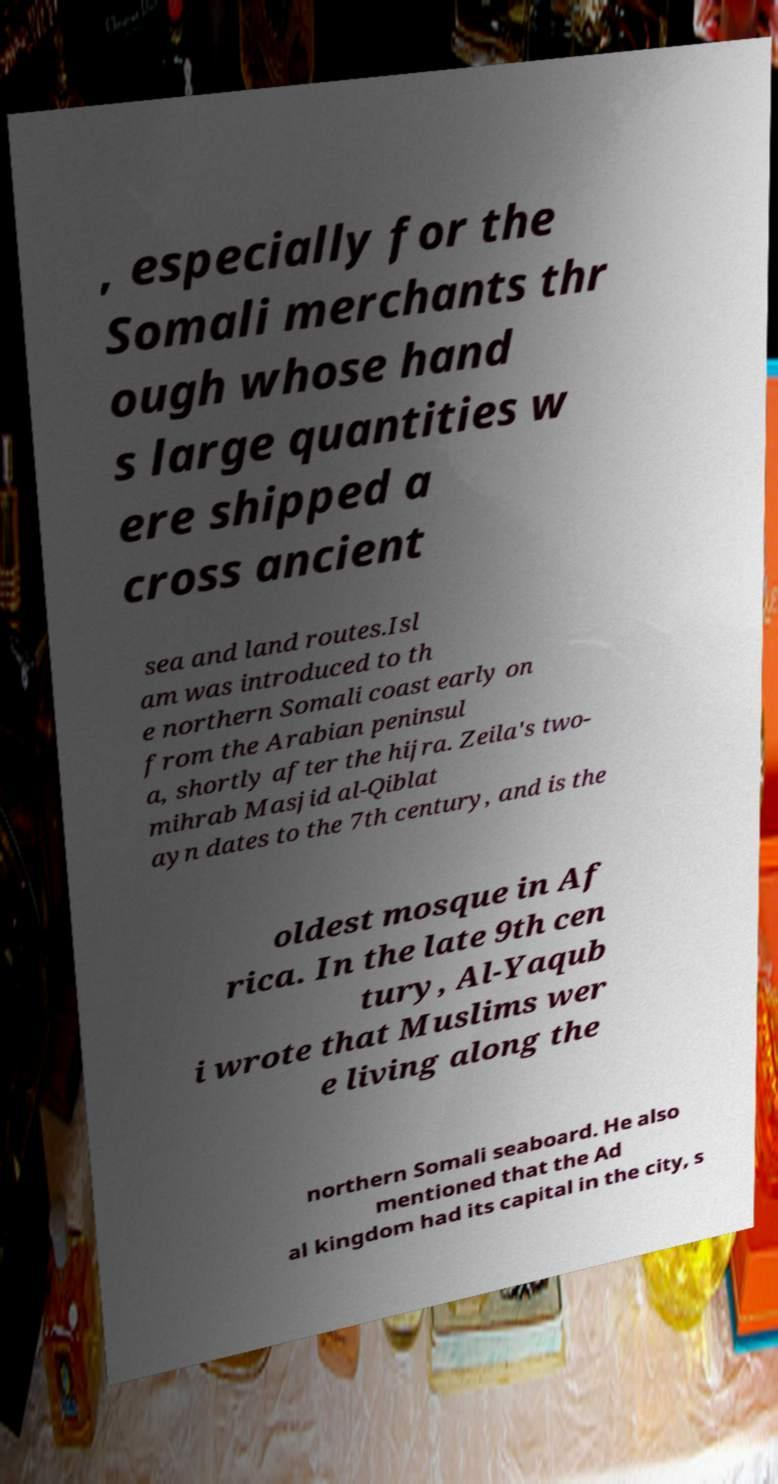Can you accurately transcribe the text from the provided image for me? , especially for the Somali merchants thr ough whose hand s large quantities w ere shipped a cross ancient sea and land routes.Isl am was introduced to th e northern Somali coast early on from the Arabian peninsul a, shortly after the hijra. Zeila's two- mihrab Masjid al-Qiblat ayn dates to the 7th century, and is the oldest mosque in Af rica. In the late 9th cen tury, Al-Yaqub i wrote that Muslims wer e living along the northern Somali seaboard. He also mentioned that the Ad al kingdom had its capital in the city, s 